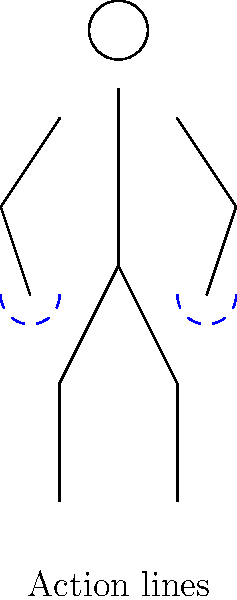As an illustrator collaborating with an author on diverse characters, you're working on a dynamic pose for a character throwing an object. Which part of the stick figure diagram is most crucial for conveying the throwing motion, and why? To answer this question, let's analyze the stick figure diagram step-by-step:

1. The diagram shows a basic stick figure with joints for head, shoulders, elbows, hands, hips, knees, and feet.

2. The most noticeable feature is the blue dashed arcs around both hands, which are labeled "Action lines."

3. Action lines in illustration are used to convey motion or direction of movement.

4. In a throwing motion, the arms and hands are the primary body parts involved in generating and directing the force.

5. The blue dashed arcs around the hands indicate a circular motion, which is typical in a throwing action (wind-up and release).

6. While other body parts like the legs and torso also contribute to a throw, the arms and hands are the most direct connection to the object being thrown.

7. As an illustrator, emphasizing the arm and hand movement through action lines helps viewers instantly recognize the throwing motion.

Therefore, the most crucial part of the stick figure diagram for conveying the throwing motion is the action lines around the hands. These lines effectively communicate the dynamic movement involved in throwing, making the character's action immediately clear to the viewer.
Answer: Action lines around the hands 